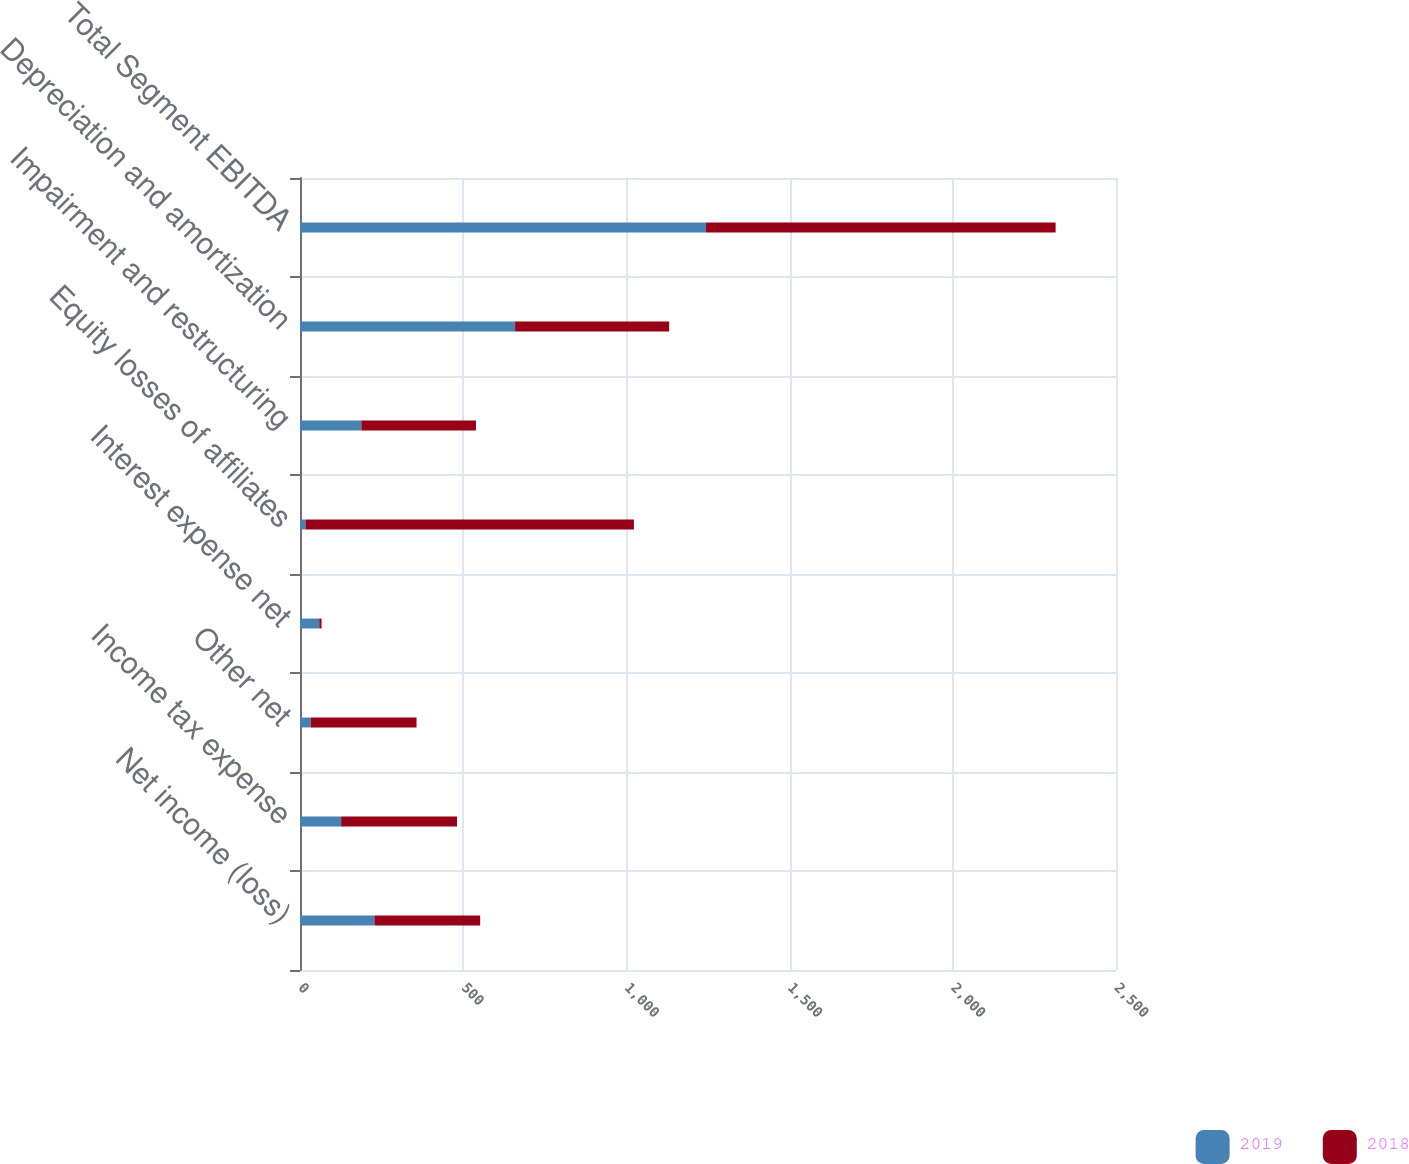<chart> <loc_0><loc_0><loc_500><loc_500><stacked_bar_chart><ecel><fcel>Net income (loss)<fcel>Income tax expense<fcel>Other net<fcel>Interest expense net<fcel>Equity losses of affiliates<fcel>Impairment and restructuring<fcel>Depreciation and amortization<fcel>Total Segment EBITDA<nl><fcel>2019<fcel>228<fcel>126<fcel>33<fcel>59<fcel>17<fcel>188<fcel>659<fcel>1244<nl><fcel>2018<fcel>324<fcel>355<fcel>324<fcel>7<fcel>1006<fcel>351<fcel>472<fcel>1071<nl></chart> 